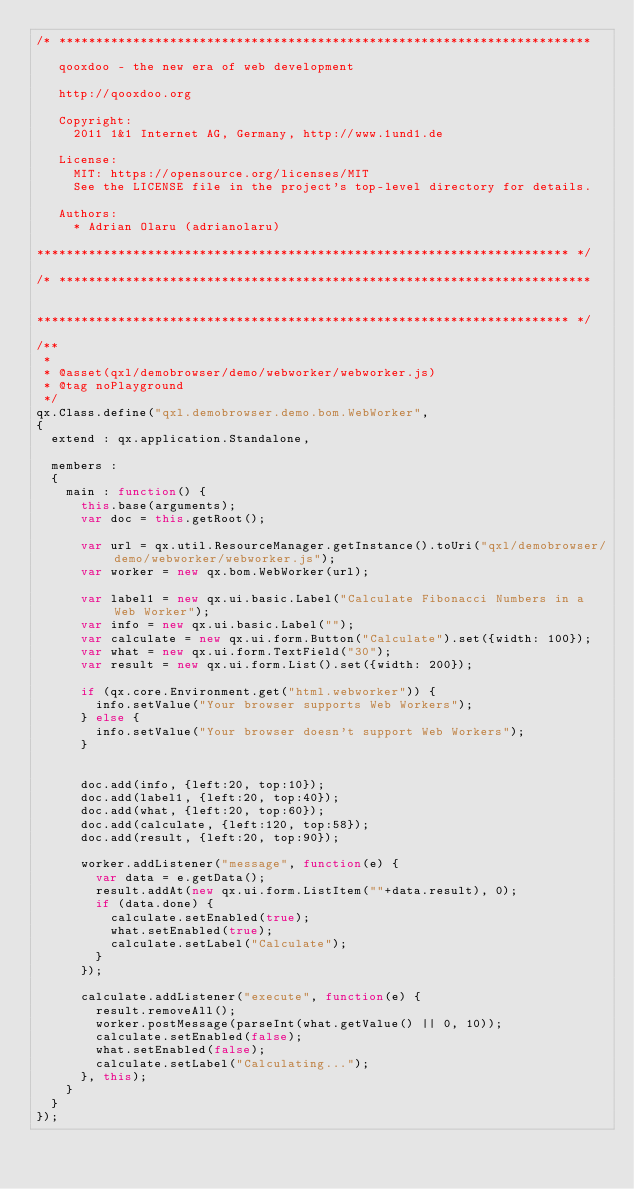Convert code to text. <code><loc_0><loc_0><loc_500><loc_500><_JavaScript_>/* ************************************************************************

   qooxdoo - the new era of web development

   http://qooxdoo.org

   Copyright:
     2011 1&1 Internet AG, Germany, http://www.1und1.de

   License:
     MIT: https://opensource.org/licenses/MIT
     See the LICENSE file in the project's top-level directory for details.

   Authors:
     * Adrian Olaru (adrianolaru)

************************************************************************ */

/* ************************************************************************


************************************************************************ */

/**
 *
 * @asset(qxl/demobrowser/demo/webworker/webworker.js)
 * @tag noPlayground
 */
qx.Class.define("qxl.demobrowser.demo.bom.WebWorker",
{
  extend : qx.application.Standalone,

  members :
  {
    main : function() {
      this.base(arguments);
      var doc = this.getRoot();

      var url = qx.util.ResourceManager.getInstance().toUri("qxl/demobrowser/demo/webworker/webworker.js");
      var worker = new qx.bom.WebWorker(url);

      var label1 = new qx.ui.basic.Label("Calculate Fibonacci Numbers in a Web Worker");
      var info = new qx.ui.basic.Label("");
      var calculate = new qx.ui.form.Button("Calculate").set({width: 100});
      var what = new qx.ui.form.TextField("30");
      var result = new qx.ui.form.List().set({width: 200});

      if (qx.core.Environment.get("html.webworker")) {
        info.setValue("Your browser supports Web Workers");
      } else {
        info.setValue("Your browser doesn't support Web Workers");
      }


      doc.add(info, {left:20, top:10});
      doc.add(label1, {left:20, top:40});
      doc.add(what, {left:20, top:60});
      doc.add(calculate, {left:120, top:58});
      doc.add(result, {left:20, top:90});

      worker.addListener("message", function(e) {
        var data = e.getData();
        result.addAt(new qx.ui.form.ListItem(""+data.result), 0);
        if (data.done) {
          calculate.setEnabled(true);
          what.setEnabled(true);
          calculate.setLabel("Calculate");
        }
      });

      calculate.addListener("execute", function(e) {
        result.removeAll();
        worker.postMessage(parseInt(what.getValue() || 0, 10));
        calculate.setEnabled(false);
        what.setEnabled(false);
        calculate.setLabel("Calculating...");
      }, this);
    }
  }
});
</code> 